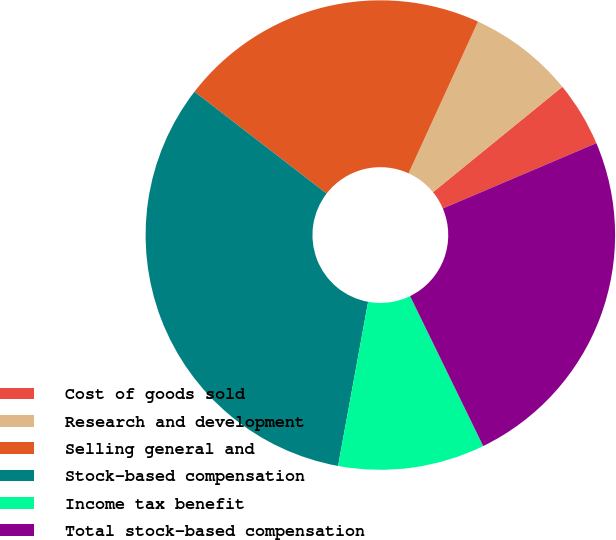<chart> <loc_0><loc_0><loc_500><loc_500><pie_chart><fcel>Cost of goods sold<fcel>Research and development<fcel>Selling general and<fcel>Stock-based compensation<fcel>Income tax benefit<fcel>Total stock-based compensation<nl><fcel>4.48%<fcel>7.29%<fcel>21.37%<fcel>32.57%<fcel>10.1%<fcel>24.18%<nl></chart> 